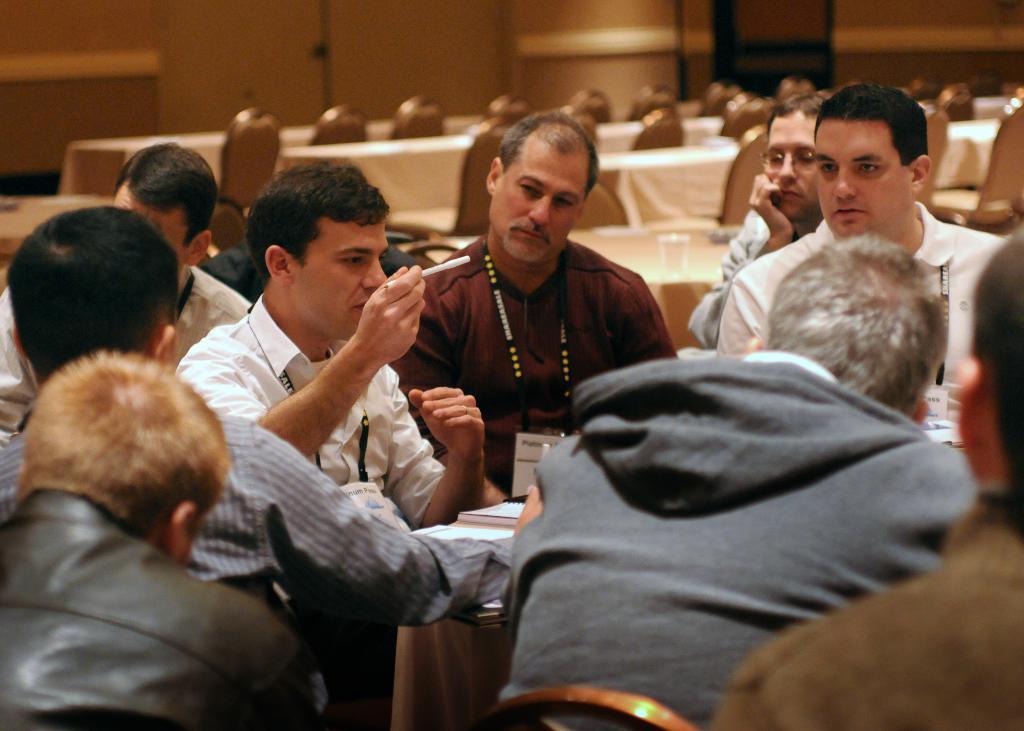In one or two sentences, can you explain what this image depicts? In this picture we can see some people are sitting on the chairs, in-front of them, we can see a table. On the table we can see the books. In the background of the image we can see the chairs, tables are covered with clothes. At the top of the image we can see the wall and door. 